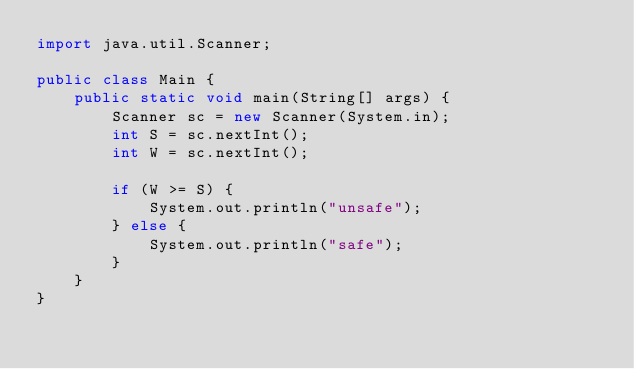Convert code to text. <code><loc_0><loc_0><loc_500><loc_500><_Java_>import java.util.Scanner;

public class Main {
    public static void main(String[] args) {
        Scanner sc = new Scanner(System.in);
        int S = sc.nextInt();
        int W = sc.nextInt();

        if (W >= S) {
            System.out.println("unsafe");
        } else {
            System.out.println("safe");
        }
    }
}</code> 